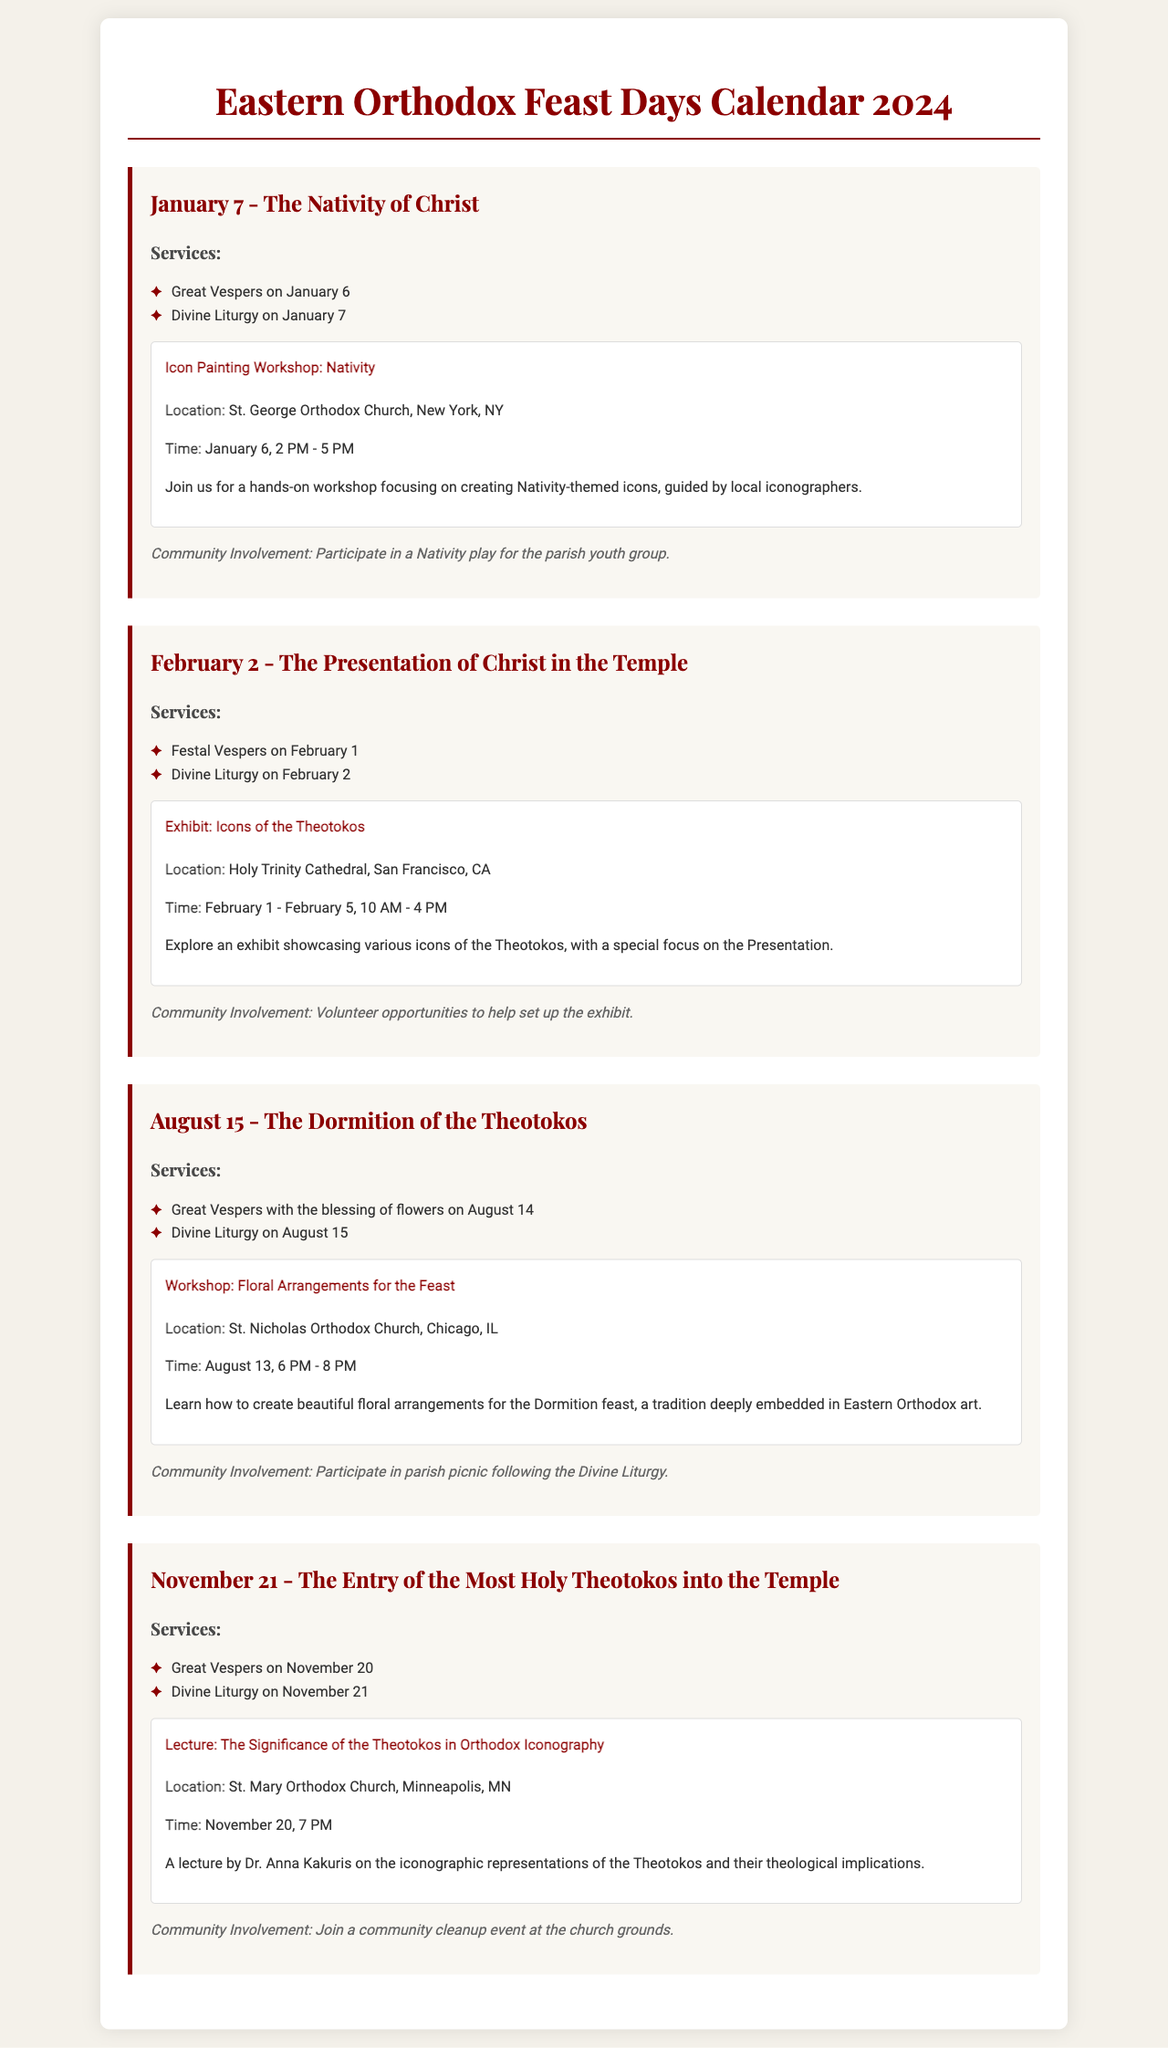What is the date of the Nativity of Christ? The Nativity of Christ is celebrated on January 7, as indicated in the document.
Answer: January 7 What is the location of the icon painting workshop for the Nativity? The icon painting workshop for the Nativity is held at St. George Orthodox Church in New York, NY.
Answer: St. George Orthodox Church, New York, NY How long is the exhibit on Icons of the Theotokos open? The exhibit on Icons of the Theotokos is open for five days, from February 1 to February 5.
Answer: February 1 - February 5 What community involvement opportunity is mentioned for the August 15 feast? For the August 15 feast, the community involvement opportunity is participating in a parish picnic.
Answer: Parish picnic Who is the speaker for the November 20 lecture? The speaker for the November 20 lecture is Dr. Anna Kakuris, as noted in the document.
Answer: Dr. Anna Kakuris What service occurs on the evening before the Presentation of Christ in the Temple? The service that occurs on the evening before the Presentation of Christ in the Temple is Festal Vespers.
Answer: Festal Vespers What time does the workshop for floral arrangements take place? The workshop for floral arrangements takes place at 6 PM on August 13.
Answer: 6 PM Which event includes the blessing of flowers? The event that includes the blessing of flowers is the Great Vespers on August 14.
Answer: Great Vespers on August 14 